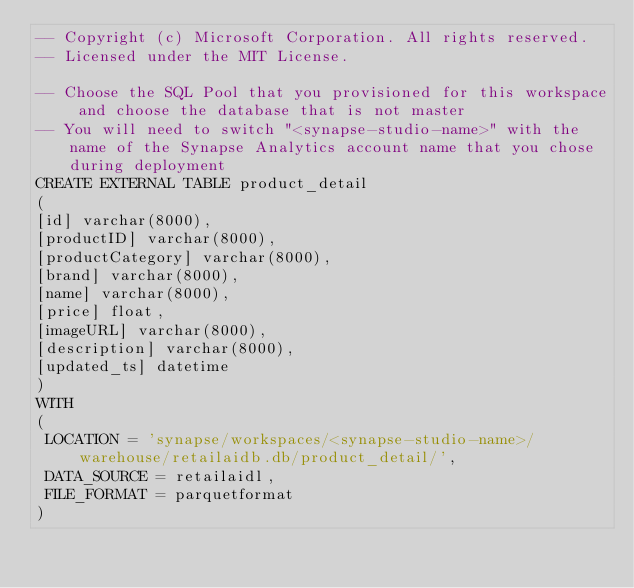Convert code to text. <code><loc_0><loc_0><loc_500><loc_500><_SQL_>-- Copyright (c) Microsoft Corporation. All rights reserved.
-- Licensed under the MIT License.

-- Choose the SQL Pool that you provisioned for this workspace and choose the database that is not master
-- You will need to switch "<synapse-studio-name>" with the name of the Synapse Analytics account name that you chose during deployment
CREATE EXTERNAL TABLE product_detail 
(
[id] varchar(8000),
[productID] varchar(8000),
[productCategory] varchar(8000),
[brand] varchar(8000),
[name] varchar(8000),
[price] float,
[imageURL] varchar(8000),
[description] varchar(8000),
[updated_ts] datetime
)
WITH
(
 LOCATION = 'synapse/workspaces/<synapse-studio-name>/warehouse/retailaidb.db/product_detail/', 
 DATA_SOURCE = retailaidl, 
 FILE_FORMAT = parquetformat
)</code> 